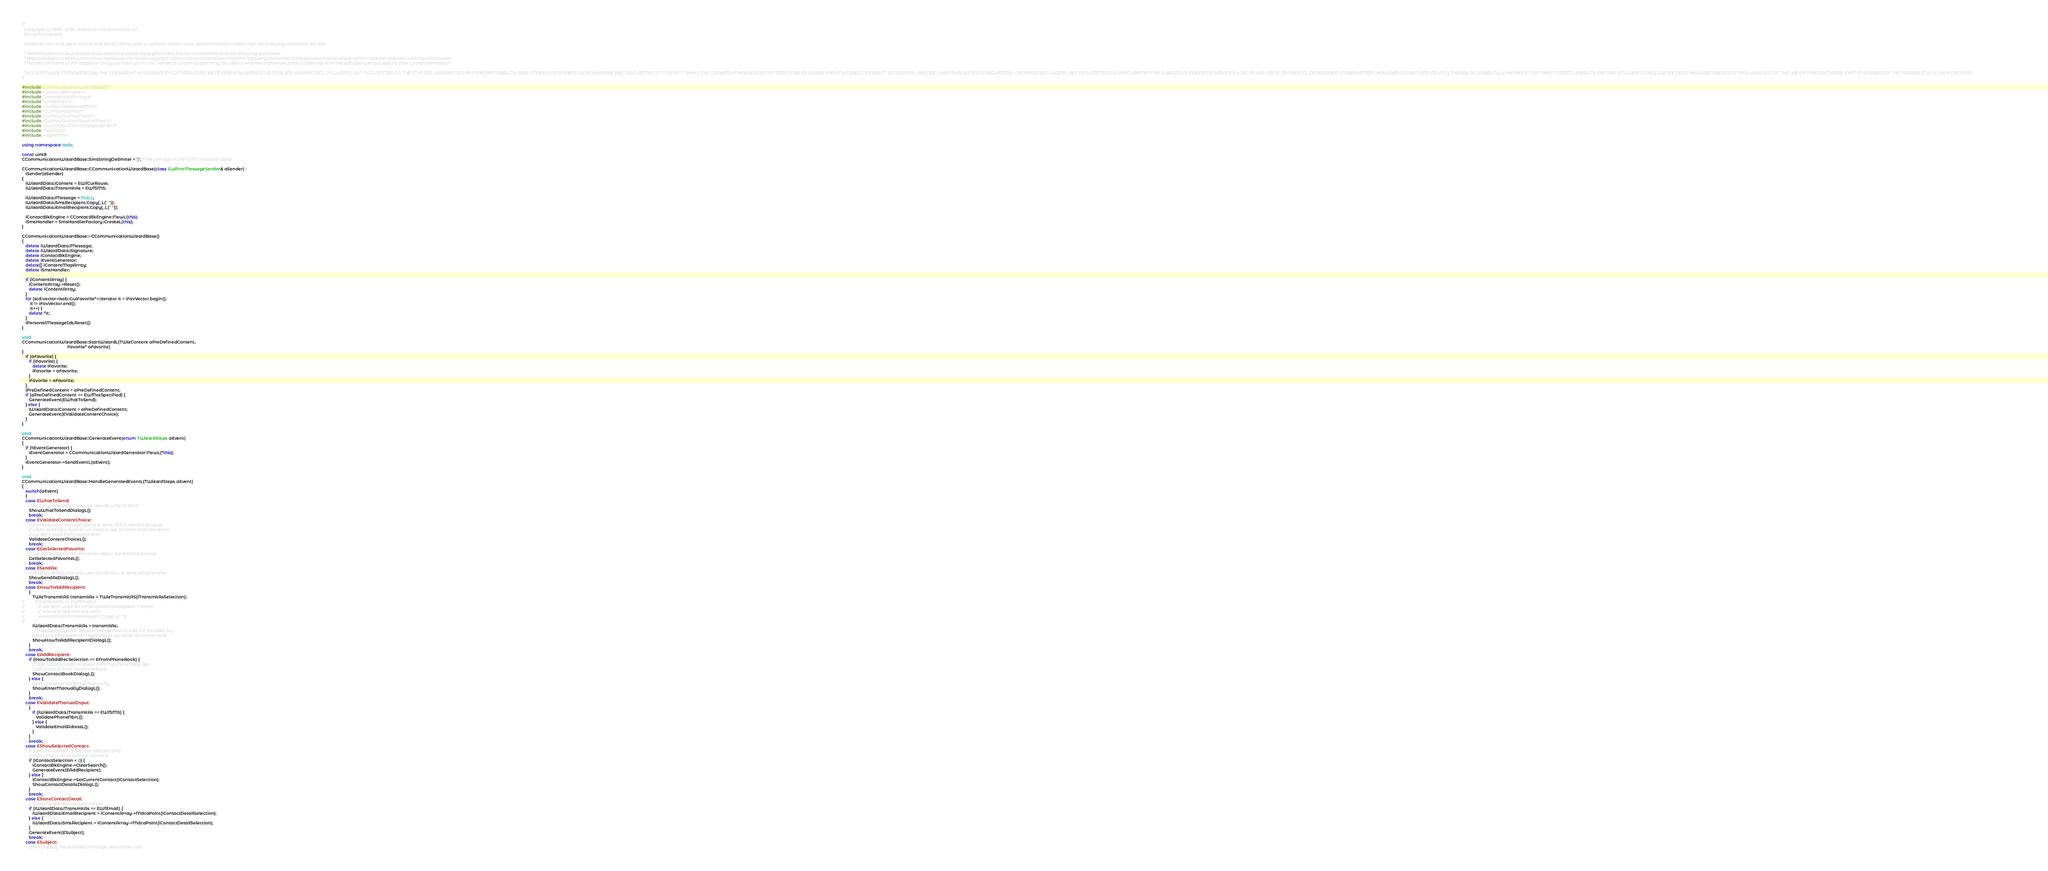Convert code to text. <code><loc_0><loc_0><loc_500><loc_500><_C++_>/*
  Copyright (c) 1999 - 2010, Vodafone Group Services Ltd
  All rights reserved.

  Redistribution and use in source and binary forms, with or without modification, are permitted provided that the following conditions are met:

  * Redistributions of source code must retain the above copyright notice, this list of conditions and the following disclaimer.
  * Redistributions in binary form must reproduce the above copyright notice, this list of conditions and the following disclaimer in the documentation and/or other materials provided with the distribution.
  * Neither the name of the Vodafone Group Services Ltd nor the names of its contributors may be used to endorse or promote products derived from this software without specific prior written permission.

  THIS SOFTWARE IS PROVIDED BY THE COPYRIGHT HOLDERS AND CONTRIBUTORS "AS IS" AND ANY EXPRESS OR IMPLIED WARRANTIES, INCLUDING, BUT NOT LIMITED TO, THE IMPLIED WARRANTIES OF MERCHANTABILITY AND FITNESS FOR A PARTICULAR PURPOSE ARE DISCLAIMED. IN NO EVENT SHALL THE COPYRIGHT HOLDER OR CONTRIBUTORS BE LIABLE FOR ANY DIRECT, INDIRECT, INCIDENTAL, SPECIAL, EXEMPLARY, OR CONSEQUENTIAL DAMAGES (INCLUDING, BUT NOT LIMITED TO, PROCUREMENT OF SUBSTITUTE GOODS OR SERVICES; LOSS OF USE, DATA, OR PROFITS; OR BUSINESS INTERRUPTION) HOWEVER CAUSED AND ON ANY THEORY OF LIABILITY, WHETHER IN CONTRACT, STRICT LIABILITY, OR TORT (INCLUDING NEGLIGENCE OR OTHERWISE) ARISING IN ANY WAY OUT OF THE USE OF THIS SOFTWARE, EVEN IF ADVISED OF THE POSSIBILITY OF SUCH DAMAGE.
*/

#include "CommunicationWizardBase.h"
#include "ContactBkEngine.h"
#include "SmsHandlerFactory.h"
#include "WFTextUtil.h"
#include "GuiProt/AdditionalInfo.h"
#include "GuiProt/Favorite.h"
#include "GuiProt/GuiProtMess.h"
#include "GuiProt/GuiProtFavoriteMess.h"
#include "GuiProt/GuiProtMessageSender.h"  
#include "nav2util.h"
#include <algorithm>

using namespace isab;

const uint8
CCommunicationWizardBase::SmsStringDelimiter = '}'; // the yen-sign in the GSM-character table.

CCommunicationWizardBase::CCommunicationWizardBase(class GuiProtMessageSender& aSender) : 
   iSender(aSender)
{
   iWizardData.iContent = EWfCurRoute;
   iWizardData.iTransmitAs = EWfSMS;

   iWizardData.iMessage = NULL;
   iWizardData.iSmsRecipient.Copy(_L(" "));
   iWizardData.iEmailRecipient.Copy(_L(" "));

   iContactBkEngine = CContactBkEngine::NewL(this);
   iSmsHandler = SmsHandlerFactory::CreateL(this);
}

CCommunicationWizardBase::~CCommunicationWizardBase()
{
   delete iWizardData.iMessage;
   delete iWizardData.iSignature;
   delete iContactBkEngine;
   delete iEventGenerator;
   delete[] iContentMapArray;
   delete iSmsHandler;

   if (iContentArray) {
      iContentArray->Reset();
      delete iContentArray;
   }
   for (std::vector<isab::GuiFavorite*>::iterator it = iFavVector.begin();
       it != iFavVector.end(); 
       it++) {
      delete *it;
   }
   iPersonalMessageIds.Reset();
}

void
CCommunicationWizardBase::StartWizardL(TWizContent aPreDefinedContent, 
                                       Favorite* aFavorite)
{
   if (aFavorite) {
      if (iFavorite) {
         delete iFavorite;
         iFavorite = aFavorite;
      }
      iFavorite = aFavorite;
   }
   iPreDefinedContent = aPreDefinedContent;
   if (aPreDefinedContent == EWfNotSpecified) {
      GenerateEvent(EWhatToSend);
   } else {
      iWizardData.iContent = aPreDefinedContent;
      GenerateEvent(EValidateContentChoice);
   }
}

void 
CCommunicationWizardBase::GenerateEvent(enum TWizardSteps aEvent)
{
   if (!iEventGenerator) {
      iEventGenerator = CCommunicationWizardGenerator::NewL(*this); 
   }
   iEventGenerator->SendEventL(aEvent);   
}

void 
CCommunicationWizardBase::HandleGeneratedEventL(TWizardSteps aEvent)
{
   switch(aEvent)
   {
   case EWhatToSend:
      // Dislplay dialog that lets user decide what to send.
      ShowWhatToSendDialogL();
      break;
   case EValidateContentChoice:
      // Validate what the user wants to send, this is needed because
      // when sending a favorite we need to ask for them from the server,
      // we don't have them stored here.
      ValidateContentChoiceL();
      break;
   case EGetSelectedFavorite:
      // Get information from the server about the selected favorite.
      GetSelectedFavoriteL();
      break;
   case ESendAs:
      // Dislplay dialog that lets user decide how to send, email or sms.
      ShowSendAsDialogL();
      break;
   case EHowToAddRecipient:
      {
         TWizTransmitAS transmitAs = TWizTransmitAS(iTransmitAsSelection);
//          if (transmitAs == EWfEmail) {
//             // We dont want an email adress as recepient if sms is 
//             // was selected and vice versa.
//             iWizardData.iEmailRecipient.Copy(_L(""));
//          }
         iWizardData.iTransmitAs = transmitAs;
         // Display dialog that lets user decide how to add the recipient, by
         // entering the phone nbr manually or by using the phone book.
         ShowHowToAddRecipientDialogL();
      }
      break;
   case EAddRecipient:
      if (iHowToAddRecSelection == EFromPhoneBook) {
         // User wants to add recipient from the phone book, get
         // all contacts from the phone book.
         ShowContactBookDialogL();
      } else {
         // Let user enter nbr/email manually.
         ShowEnterManuallyDialogL();
      }
      break;
   case EValidateManualInput:
      {
         if (iWizardData.iTransmitAs == EWfSMS) {
            ValidatePhoneNbrL();
         } else {
            ValidateEmailAdressL();
         }
      } 
      break;
   case EShowSelectedContact:
      // Store the contact id the user selected and 
      // show that contacts phone numbers.
      if (iContactSelection < 0) {
         iContactBkEngine->ClearSearch();
         GenerateEvent(EAddRecipient);
      } else {
         iContactBkEngine->SetCurrentContact(iContactSelection);
         ShowContactDetailsDialogL();
      }
      break;
   case EStoreContactDetail:
      // Store the selected contact adress.
      if (iWizardData.iTransmitAs == EWfEmail) {
         iWizardData.iEmailRecipient = iContentArray->MdcaPoint(iContactDetailSelection);
      } else {
         iWizardData.iSmsRecipient = iContentArray->MdcaPoint(iContactDetailSelection);
      }
      GenerateEvent(ESubject);
      break;
   case ESubject:
      // XXX Display the standard message, should the user </code> 